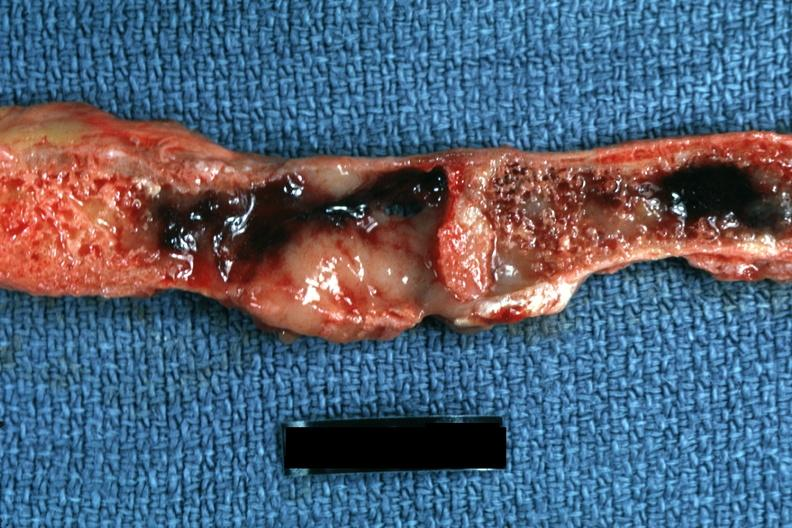what does this image show?
Answer the question using a single word or phrase. Section of sternum close-up photo showing typical myeloma lesions very good 